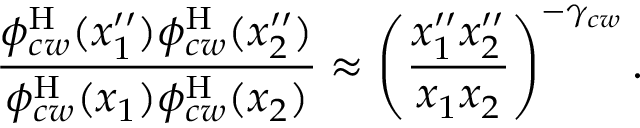<formula> <loc_0><loc_0><loc_500><loc_500>\frac { \phi _ { c w } ^ { H } ( x _ { 1 } ^ { \prime \prime } ) \phi _ { c w } ^ { H } ( x _ { 2 } ^ { \prime \prime } ) } { \phi _ { c w } ^ { H } ( x _ { 1 } ) \phi _ { c w } ^ { H } ( x _ { 2 } ) } \approx \left ( \frac { x _ { 1 } ^ { \prime \prime } x _ { 2 } ^ { \prime \prime } } { x _ { 1 } x _ { 2 } } \right ) ^ { - \gamma _ { c w } } .</formula> 